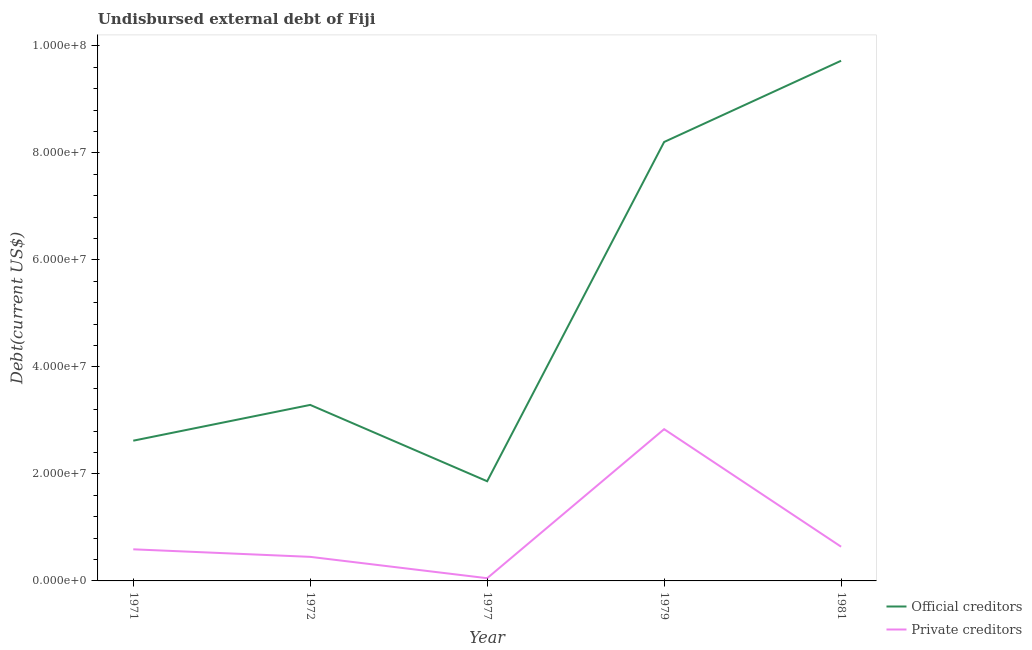How many different coloured lines are there?
Keep it short and to the point. 2. Does the line corresponding to undisbursed external debt of private creditors intersect with the line corresponding to undisbursed external debt of official creditors?
Your answer should be very brief. No. What is the undisbursed external debt of private creditors in 1972?
Offer a very short reply. 4.50e+06. Across all years, what is the maximum undisbursed external debt of private creditors?
Offer a very short reply. 2.84e+07. Across all years, what is the minimum undisbursed external debt of private creditors?
Make the answer very short. 5.07e+05. In which year was the undisbursed external debt of official creditors maximum?
Your response must be concise. 1981. What is the total undisbursed external debt of private creditors in the graph?
Your answer should be very brief. 4.57e+07. What is the difference between the undisbursed external debt of official creditors in 1972 and that in 1979?
Provide a succinct answer. -4.91e+07. What is the difference between the undisbursed external debt of private creditors in 1979 and the undisbursed external debt of official creditors in 1971?
Give a very brief answer. 2.15e+06. What is the average undisbursed external debt of private creditors per year?
Provide a succinct answer. 9.13e+06. In the year 1972, what is the difference between the undisbursed external debt of official creditors and undisbursed external debt of private creditors?
Provide a short and direct response. 2.84e+07. What is the ratio of the undisbursed external debt of private creditors in 1979 to that in 1981?
Your answer should be compact. 4.44. What is the difference between the highest and the second highest undisbursed external debt of private creditors?
Your response must be concise. 2.20e+07. What is the difference between the highest and the lowest undisbursed external debt of private creditors?
Give a very brief answer. 2.79e+07. Is the sum of the undisbursed external debt of private creditors in 1977 and 1981 greater than the maximum undisbursed external debt of official creditors across all years?
Your response must be concise. No. Is the undisbursed external debt of private creditors strictly greater than the undisbursed external debt of official creditors over the years?
Provide a short and direct response. No. Is the undisbursed external debt of private creditors strictly less than the undisbursed external debt of official creditors over the years?
Ensure brevity in your answer.  Yes. How many lines are there?
Offer a very short reply. 2. How many years are there in the graph?
Keep it short and to the point. 5. Does the graph contain any zero values?
Ensure brevity in your answer.  No. Does the graph contain grids?
Your response must be concise. No. How many legend labels are there?
Offer a very short reply. 2. How are the legend labels stacked?
Give a very brief answer. Vertical. What is the title of the graph?
Keep it short and to the point. Undisbursed external debt of Fiji. What is the label or title of the Y-axis?
Your answer should be compact. Debt(current US$). What is the Debt(current US$) of Official creditors in 1971?
Provide a succinct answer. 2.62e+07. What is the Debt(current US$) of Private creditors in 1971?
Your response must be concise. 5.91e+06. What is the Debt(current US$) of Official creditors in 1972?
Ensure brevity in your answer.  3.29e+07. What is the Debt(current US$) of Private creditors in 1972?
Make the answer very short. 4.50e+06. What is the Debt(current US$) of Official creditors in 1977?
Provide a succinct answer. 1.86e+07. What is the Debt(current US$) in Private creditors in 1977?
Offer a very short reply. 5.07e+05. What is the Debt(current US$) of Official creditors in 1979?
Ensure brevity in your answer.  8.20e+07. What is the Debt(current US$) of Private creditors in 1979?
Provide a succinct answer. 2.84e+07. What is the Debt(current US$) of Official creditors in 1981?
Offer a terse response. 9.72e+07. What is the Debt(current US$) of Private creditors in 1981?
Ensure brevity in your answer.  6.39e+06. Across all years, what is the maximum Debt(current US$) of Official creditors?
Your response must be concise. 9.72e+07. Across all years, what is the maximum Debt(current US$) of Private creditors?
Your answer should be very brief. 2.84e+07. Across all years, what is the minimum Debt(current US$) of Official creditors?
Offer a very short reply. 1.86e+07. Across all years, what is the minimum Debt(current US$) in Private creditors?
Provide a short and direct response. 5.07e+05. What is the total Debt(current US$) of Official creditors in the graph?
Offer a terse response. 2.57e+08. What is the total Debt(current US$) in Private creditors in the graph?
Ensure brevity in your answer.  4.57e+07. What is the difference between the Debt(current US$) of Official creditors in 1971 and that in 1972?
Your response must be concise. -6.68e+06. What is the difference between the Debt(current US$) of Private creditors in 1971 and that in 1972?
Provide a short and direct response. 1.41e+06. What is the difference between the Debt(current US$) of Official creditors in 1971 and that in 1977?
Provide a succinct answer. 7.58e+06. What is the difference between the Debt(current US$) of Private creditors in 1971 and that in 1977?
Provide a succinct answer. 5.40e+06. What is the difference between the Debt(current US$) of Official creditors in 1971 and that in 1979?
Your answer should be very brief. -5.58e+07. What is the difference between the Debt(current US$) of Private creditors in 1971 and that in 1979?
Your response must be concise. -2.25e+07. What is the difference between the Debt(current US$) of Official creditors in 1971 and that in 1981?
Provide a succinct answer. -7.10e+07. What is the difference between the Debt(current US$) of Private creditors in 1971 and that in 1981?
Ensure brevity in your answer.  -4.86e+05. What is the difference between the Debt(current US$) in Official creditors in 1972 and that in 1977?
Offer a very short reply. 1.43e+07. What is the difference between the Debt(current US$) of Private creditors in 1972 and that in 1977?
Ensure brevity in your answer.  3.99e+06. What is the difference between the Debt(current US$) in Official creditors in 1972 and that in 1979?
Offer a terse response. -4.91e+07. What is the difference between the Debt(current US$) of Private creditors in 1972 and that in 1979?
Offer a very short reply. -2.39e+07. What is the difference between the Debt(current US$) of Official creditors in 1972 and that in 1981?
Your answer should be very brief. -6.43e+07. What is the difference between the Debt(current US$) in Private creditors in 1972 and that in 1981?
Provide a short and direct response. -1.90e+06. What is the difference between the Debt(current US$) of Official creditors in 1977 and that in 1979?
Keep it short and to the point. -6.34e+07. What is the difference between the Debt(current US$) in Private creditors in 1977 and that in 1979?
Give a very brief answer. -2.79e+07. What is the difference between the Debt(current US$) in Official creditors in 1977 and that in 1981?
Offer a very short reply. -7.86e+07. What is the difference between the Debt(current US$) in Private creditors in 1977 and that in 1981?
Your answer should be compact. -5.89e+06. What is the difference between the Debt(current US$) of Official creditors in 1979 and that in 1981?
Offer a very short reply. -1.52e+07. What is the difference between the Debt(current US$) of Private creditors in 1979 and that in 1981?
Provide a short and direct response. 2.20e+07. What is the difference between the Debt(current US$) in Official creditors in 1971 and the Debt(current US$) in Private creditors in 1972?
Keep it short and to the point. 2.17e+07. What is the difference between the Debt(current US$) of Official creditors in 1971 and the Debt(current US$) of Private creditors in 1977?
Make the answer very short. 2.57e+07. What is the difference between the Debt(current US$) in Official creditors in 1971 and the Debt(current US$) in Private creditors in 1979?
Offer a very short reply. -2.15e+06. What is the difference between the Debt(current US$) in Official creditors in 1971 and the Debt(current US$) in Private creditors in 1981?
Ensure brevity in your answer.  1.98e+07. What is the difference between the Debt(current US$) of Official creditors in 1972 and the Debt(current US$) of Private creditors in 1977?
Make the answer very short. 3.24e+07. What is the difference between the Debt(current US$) in Official creditors in 1972 and the Debt(current US$) in Private creditors in 1979?
Your answer should be compact. 4.53e+06. What is the difference between the Debt(current US$) of Official creditors in 1972 and the Debt(current US$) of Private creditors in 1981?
Give a very brief answer. 2.65e+07. What is the difference between the Debt(current US$) in Official creditors in 1977 and the Debt(current US$) in Private creditors in 1979?
Provide a succinct answer. -9.73e+06. What is the difference between the Debt(current US$) in Official creditors in 1977 and the Debt(current US$) in Private creditors in 1981?
Ensure brevity in your answer.  1.22e+07. What is the difference between the Debt(current US$) of Official creditors in 1979 and the Debt(current US$) of Private creditors in 1981?
Your response must be concise. 7.56e+07. What is the average Debt(current US$) in Official creditors per year?
Make the answer very short. 5.14e+07. What is the average Debt(current US$) in Private creditors per year?
Your answer should be compact. 9.13e+06. In the year 1971, what is the difference between the Debt(current US$) of Official creditors and Debt(current US$) of Private creditors?
Offer a terse response. 2.03e+07. In the year 1972, what is the difference between the Debt(current US$) in Official creditors and Debt(current US$) in Private creditors?
Ensure brevity in your answer.  2.84e+07. In the year 1977, what is the difference between the Debt(current US$) of Official creditors and Debt(current US$) of Private creditors?
Provide a short and direct response. 1.81e+07. In the year 1979, what is the difference between the Debt(current US$) of Official creditors and Debt(current US$) of Private creditors?
Keep it short and to the point. 5.37e+07. In the year 1981, what is the difference between the Debt(current US$) in Official creditors and Debt(current US$) in Private creditors?
Ensure brevity in your answer.  9.08e+07. What is the ratio of the Debt(current US$) in Official creditors in 1971 to that in 1972?
Your answer should be compact. 0.8. What is the ratio of the Debt(current US$) of Private creditors in 1971 to that in 1972?
Provide a short and direct response. 1.31. What is the ratio of the Debt(current US$) in Official creditors in 1971 to that in 1977?
Your response must be concise. 1.41. What is the ratio of the Debt(current US$) in Private creditors in 1971 to that in 1977?
Your response must be concise. 11.65. What is the ratio of the Debt(current US$) of Official creditors in 1971 to that in 1979?
Keep it short and to the point. 0.32. What is the ratio of the Debt(current US$) of Private creditors in 1971 to that in 1979?
Provide a succinct answer. 0.21. What is the ratio of the Debt(current US$) in Official creditors in 1971 to that in 1981?
Provide a succinct answer. 0.27. What is the ratio of the Debt(current US$) in Private creditors in 1971 to that in 1981?
Offer a very short reply. 0.92. What is the ratio of the Debt(current US$) of Official creditors in 1972 to that in 1977?
Provide a short and direct response. 1.77. What is the ratio of the Debt(current US$) in Private creditors in 1972 to that in 1977?
Give a very brief answer. 8.87. What is the ratio of the Debt(current US$) in Official creditors in 1972 to that in 1979?
Your response must be concise. 0.4. What is the ratio of the Debt(current US$) of Private creditors in 1972 to that in 1979?
Your response must be concise. 0.16. What is the ratio of the Debt(current US$) in Official creditors in 1972 to that in 1981?
Ensure brevity in your answer.  0.34. What is the ratio of the Debt(current US$) in Private creditors in 1972 to that in 1981?
Your answer should be very brief. 0.7. What is the ratio of the Debt(current US$) of Official creditors in 1977 to that in 1979?
Offer a very short reply. 0.23. What is the ratio of the Debt(current US$) in Private creditors in 1977 to that in 1979?
Keep it short and to the point. 0.02. What is the ratio of the Debt(current US$) in Official creditors in 1977 to that in 1981?
Your response must be concise. 0.19. What is the ratio of the Debt(current US$) of Private creditors in 1977 to that in 1981?
Make the answer very short. 0.08. What is the ratio of the Debt(current US$) of Official creditors in 1979 to that in 1981?
Keep it short and to the point. 0.84. What is the ratio of the Debt(current US$) in Private creditors in 1979 to that in 1981?
Give a very brief answer. 4.44. What is the difference between the highest and the second highest Debt(current US$) in Official creditors?
Your answer should be compact. 1.52e+07. What is the difference between the highest and the second highest Debt(current US$) in Private creditors?
Provide a short and direct response. 2.20e+07. What is the difference between the highest and the lowest Debt(current US$) in Official creditors?
Keep it short and to the point. 7.86e+07. What is the difference between the highest and the lowest Debt(current US$) in Private creditors?
Keep it short and to the point. 2.79e+07. 